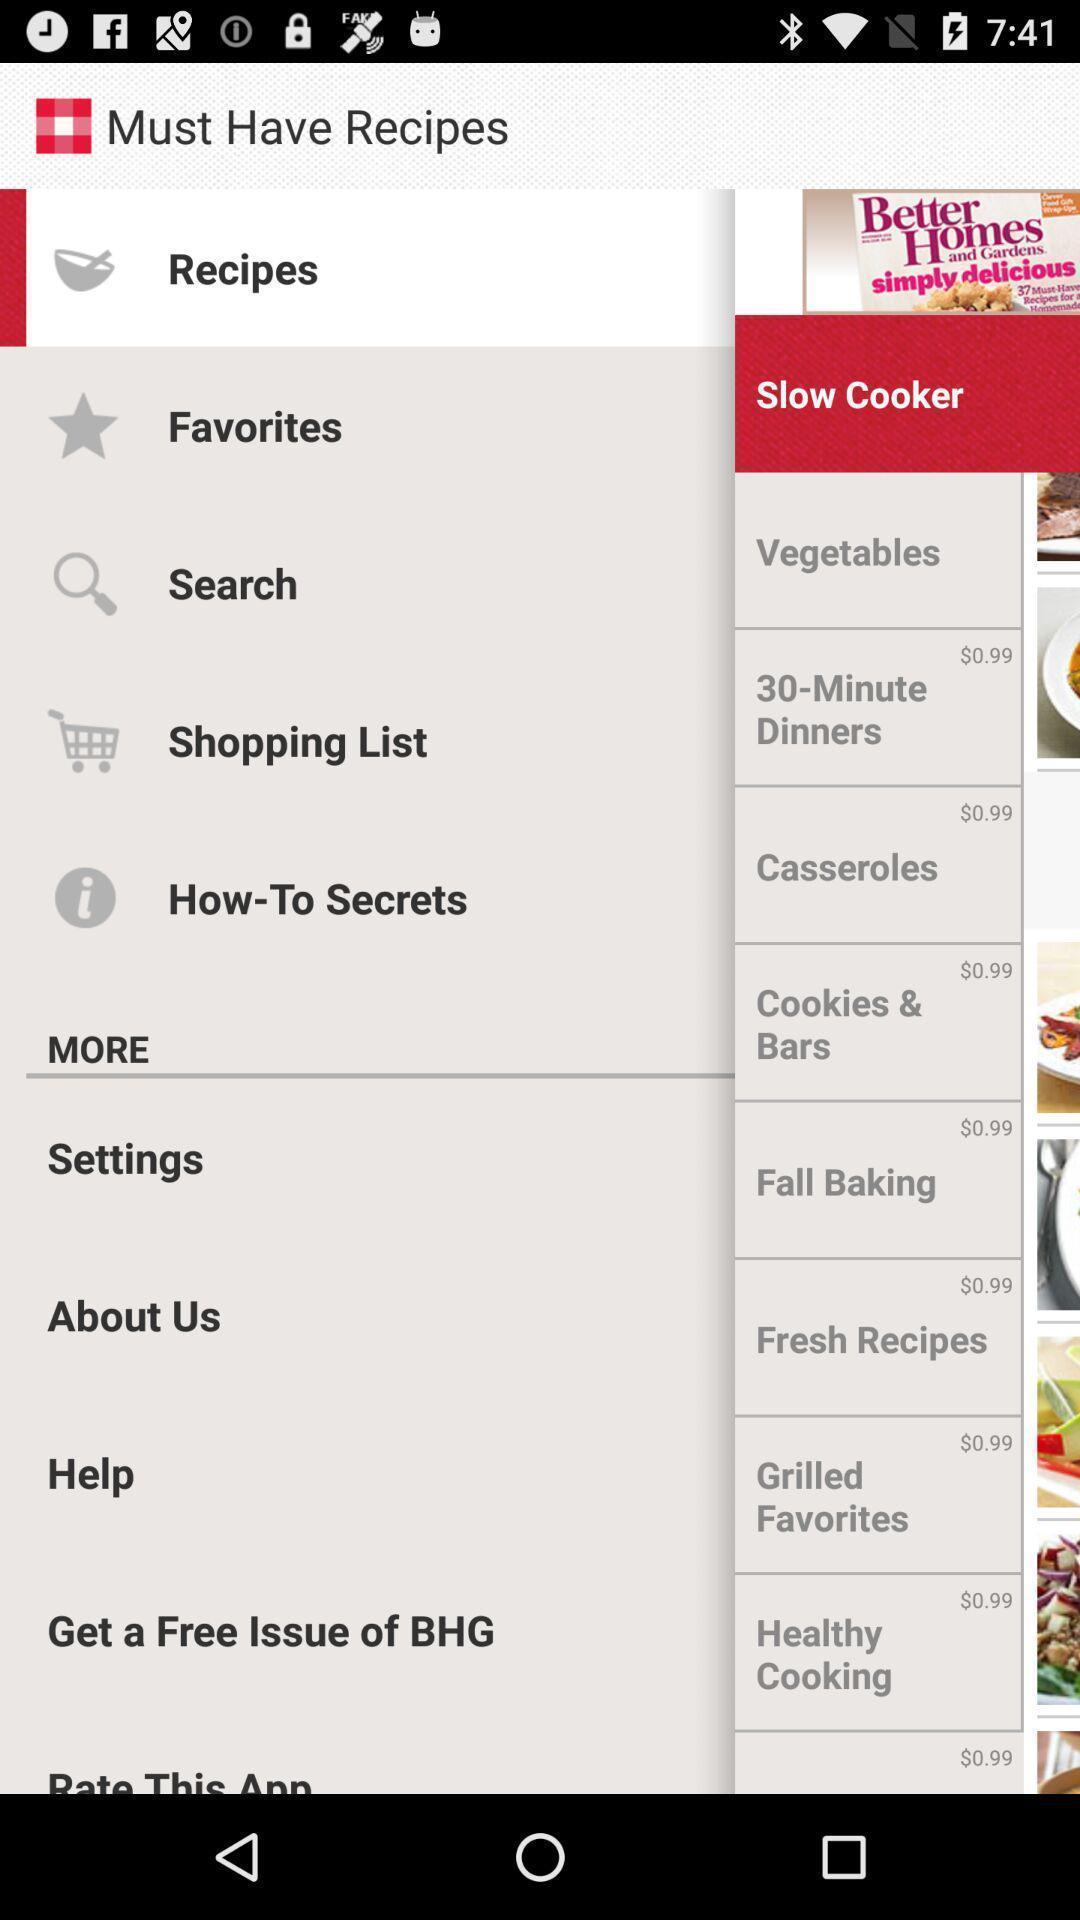Tell me about the visual elements in this screen capture. Page showing various options on cooking app. 